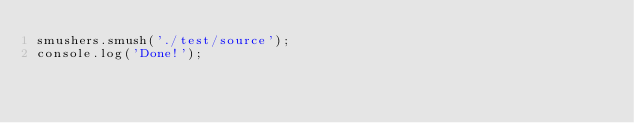Convert code to text. <code><loc_0><loc_0><loc_500><loc_500><_JavaScript_>smushers.smush('./test/source');
console.log('Done!');</code> 